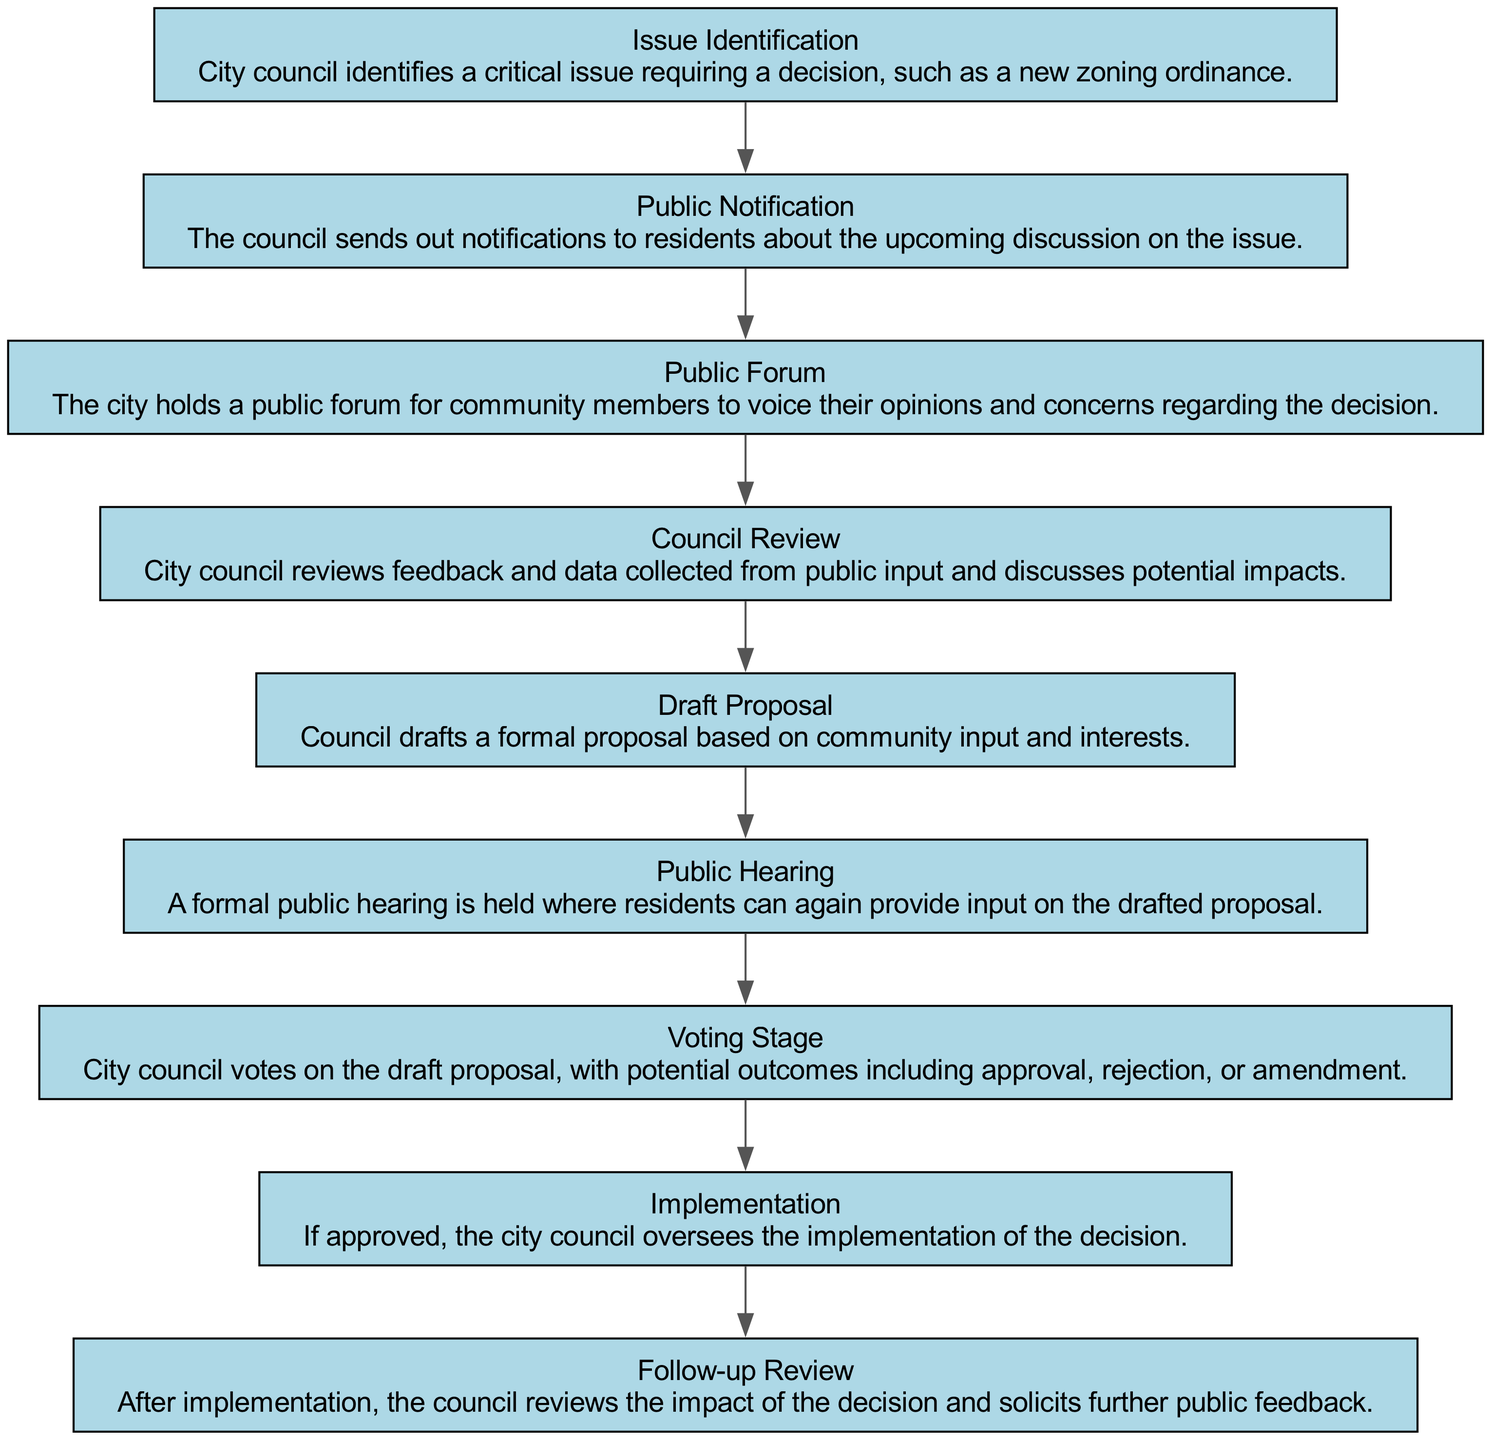What is the first step in the timeline? The diagram starts with the "Issue Identification" node, which is the first process where the city council identifies a critical issue needing a decision.
Answer: Issue Identification How many stages involve public input? The stages that involve public input are "Public Forum" and "Public Hearing," totaling two stages.
Answer: 2 What follows the "Draft Proposal"? After "Draft Proposal," the next step in the flow is the "Public Hearing."
Answer: Public Hearing Which stage comes immediately after the "Voting Stage"? After the "Voting Stage," the next stage listed is "Implementation."
Answer: Implementation What is the outcome of the "Voting Stage"? The outcomes of the "Voting Stage" can be approval, rejection, or amendment of the draft proposal.
Answer: Approval, rejection, or amendment How many total elements are in the diagram? The diagram has a total of nine elements, including all the stages in the timeline.
Answer: 9 Which stage directly leads to reviewing the decision's impact? The "Follow-up Review" stage directly follows the "Implementation" stage, which involves reviewing the decision's impact.
Answer: Follow-up Review Identify the two nodes that denote phases of public input in the process. The nodes are "Public Forum" and "Public Hearing," which are dedicated to gathering public feedback and concerns.
Answer: Public Forum and Public Hearing What is the description associated with the "Council Review"? The "Council Review" stage discusses feedback and data collected from public input and potential impacts.
Answer: City council reviews feedback and data collected from public input and discusses potential impacts 